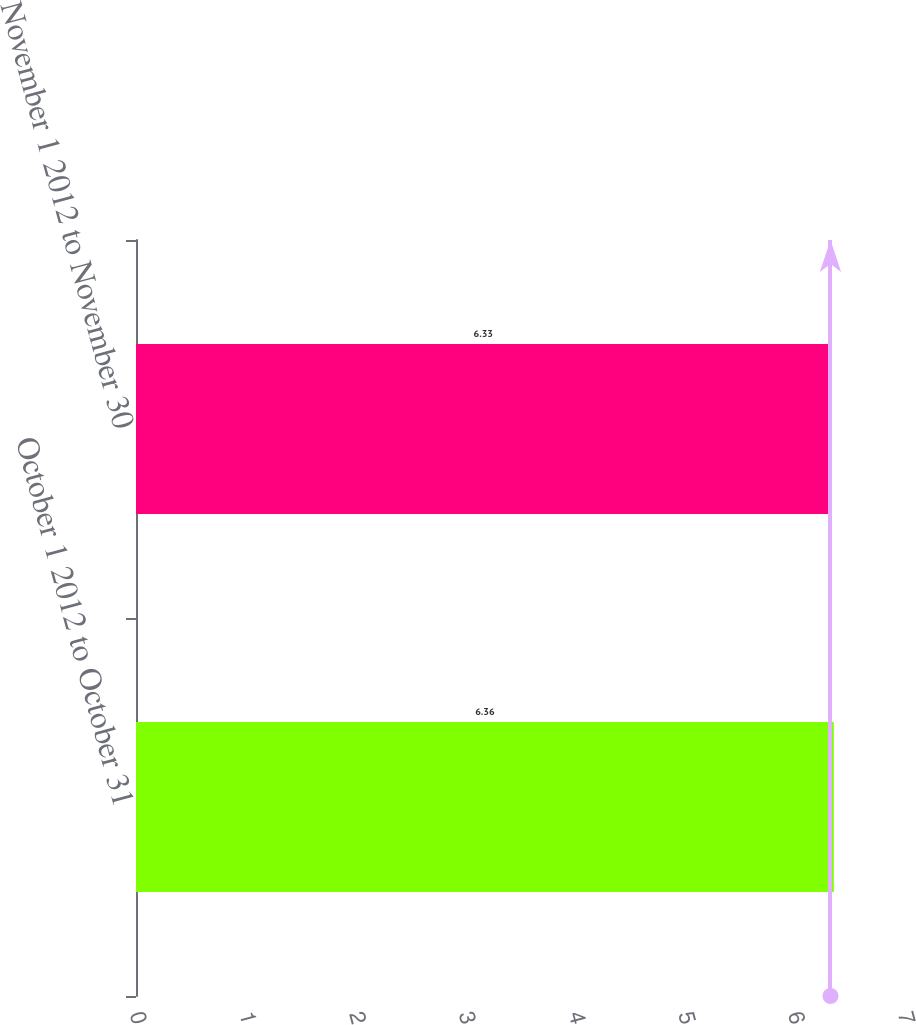Convert chart. <chart><loc_0><loc_0><loc_500><loc_500><bar_chart><fcel>October 1 2012 to October 31<fcel>November 1 2012 to November 30<nl><fcel>6.36<fcel>6.33<nl></chart> 